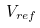<formula> <loc_0><loc_0><loc_500><loc_500>V _ { r e f }</formula> 